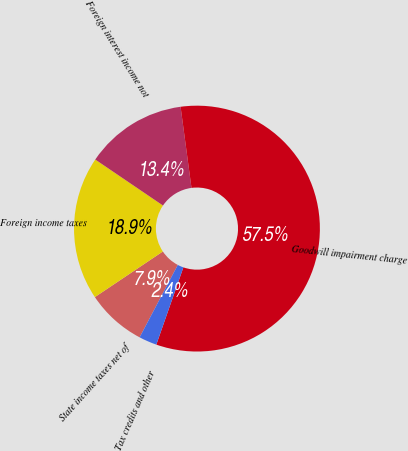Convert chart. <chart><loc_0><loc_0><loc_500><loc_500><pie_chart><fcel>State income taxes net of<fcel>Foreign income taxes<fcel>Foreign interest income not<fcel>Goodwill impairment charge<fcel>Tax credits and other<nl><fcel>7.87%<fcel>18.9%<fcel>13.38%<fcel>57.49%<fcel>2.36%<nl></chart> 